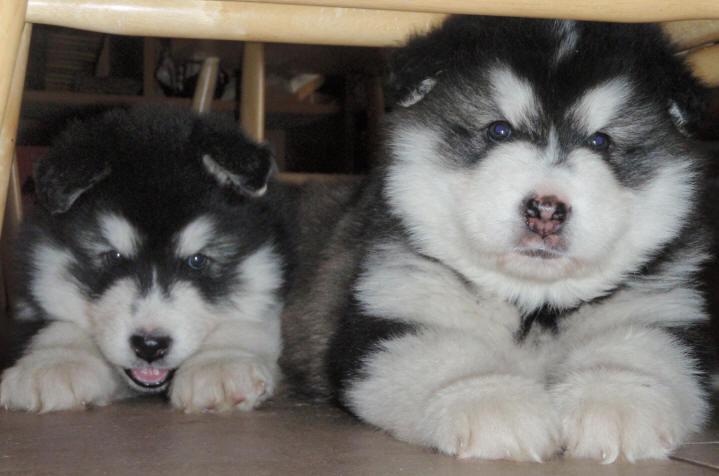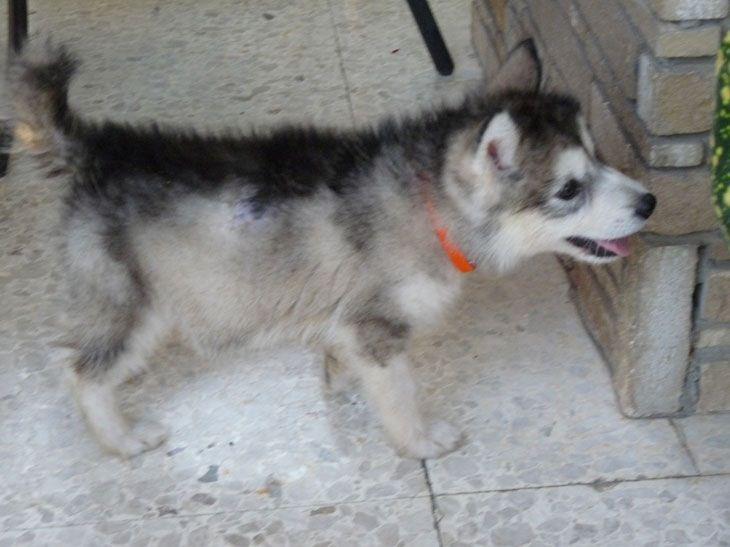The first image is the image on the left, the second image is the image on the right. Examine the images to the left and right. Is the description "All dogs are young husky puppies, the combined images include at least two black-and-white puppies, and one image shows a pair of puppies with all floppy ears, posed side-by-side and facing the camera." accurate? Answer yes or no. Yes. The first image is the image on the left, the second image is the image on the right. Given the left and right images, does the statement "There are three dogs" hold true? Answer yes or no. Yes. 